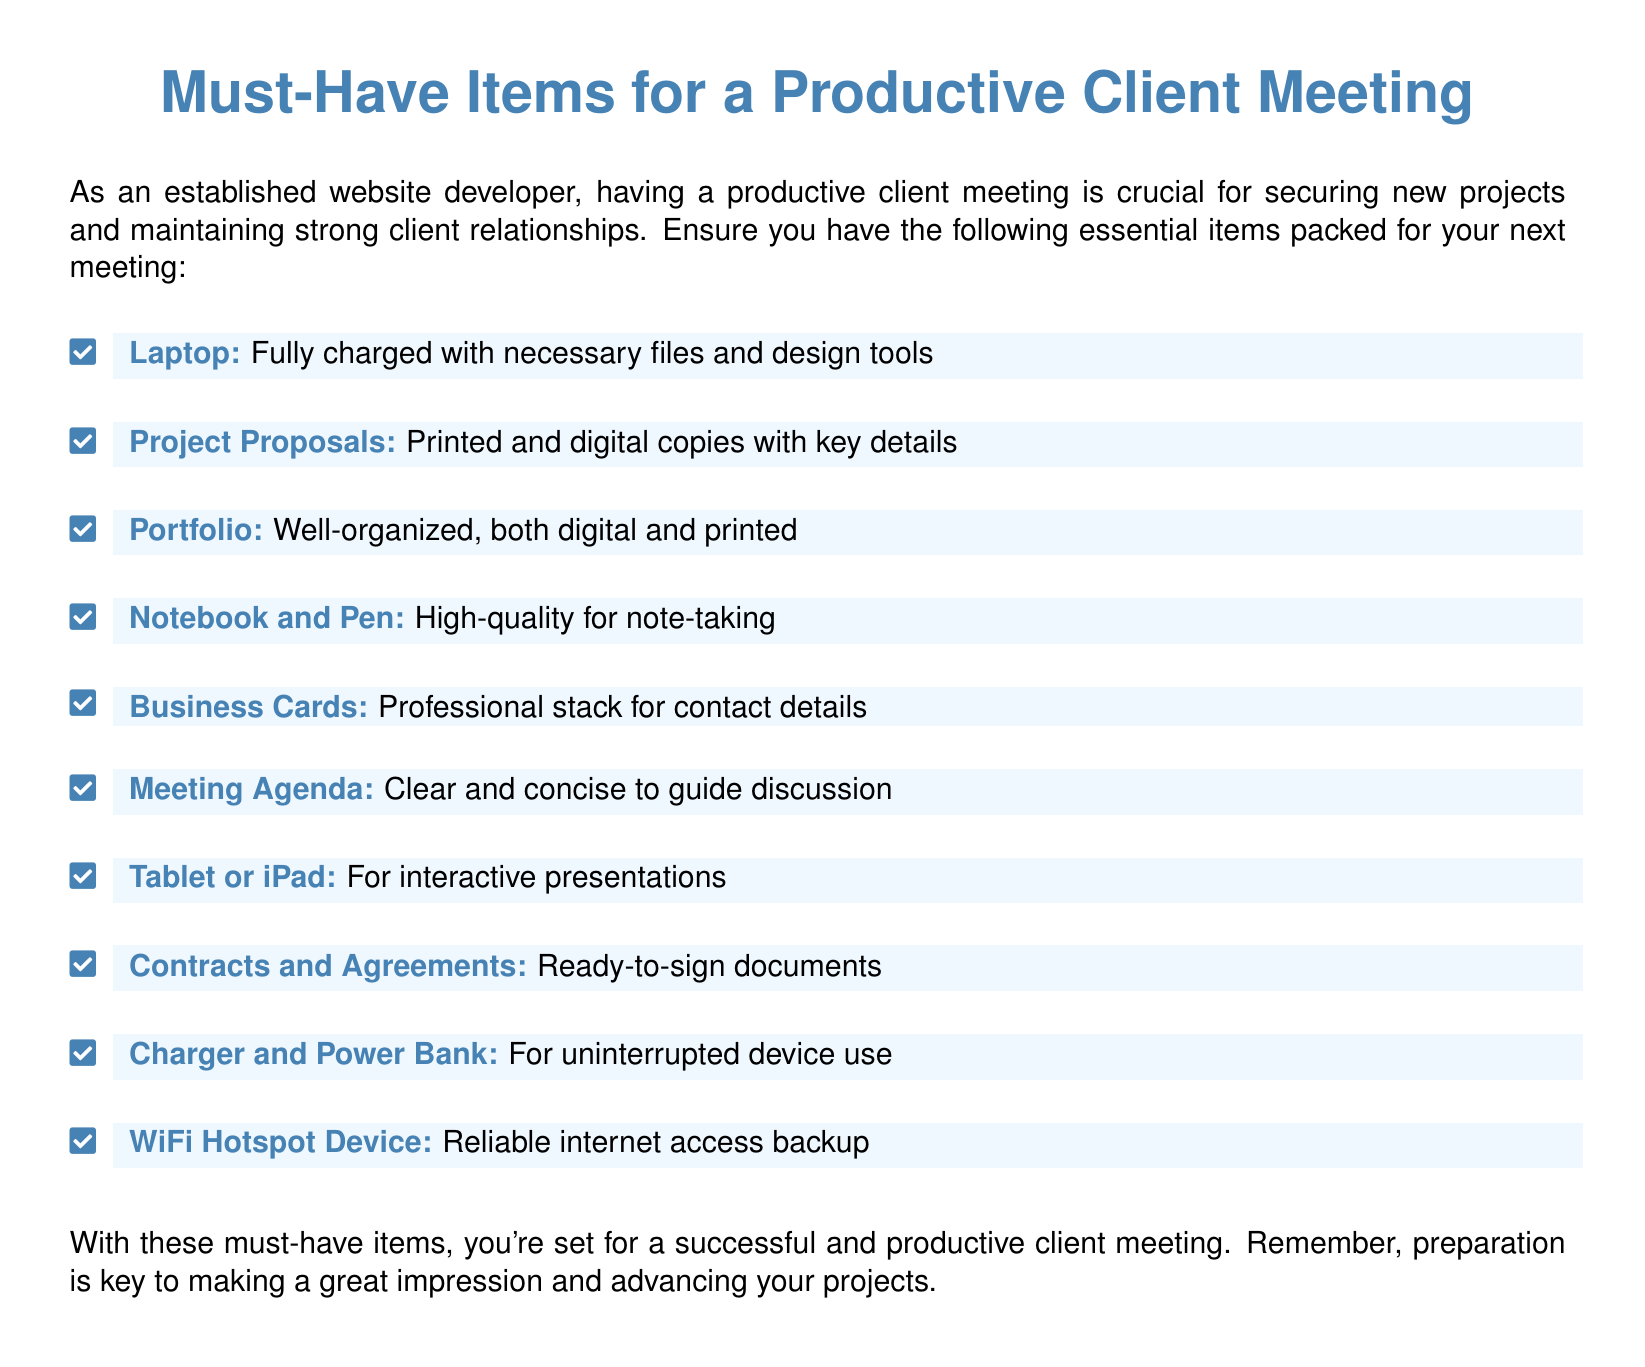what item is listed for internet access? The document specifies a WiFi Hotspot Device as a backup for reliable internet access.
Answer: WiFi Hotspot Device how many items are listed in total? The document contains a list of must-have items for a productive client meeting, which totals ten items.
Answer: 10 what should you bring for note-taking? A Notebook and Pen are suggested as essential items for note-taking during the meeting.
Answer: Notebook and Pen are printed project proposals required? Yes, the document mentions both printed and digital copies of Project Proposals as necessary for the meeting.
Answer: Yes what is the main color used in the document? The main color specified in the document is defined by the hex code 4682B4.
Answer: 4682B4 what purpose does the Meeting Agenda serve? The Meeting Agenda is intended to guide the discussion during the client meeting, as mentioned in the document.
Answer: Guide discussion should you have a charger with you? Yes, the document indicates that a Charger and Power Bank are important for uninterrupted device use.
Answer: Yes what type of device is suggested for presentations? A Tablet or iPad is recommended for interactive presentations in the meeting.
Answer: Tablet or iPad what must be prepared before the meeting regarding legal documents? Contracts and Agreements should be ready-to-sign, as stated in the document.
Answer: Ready-to-sign documents 